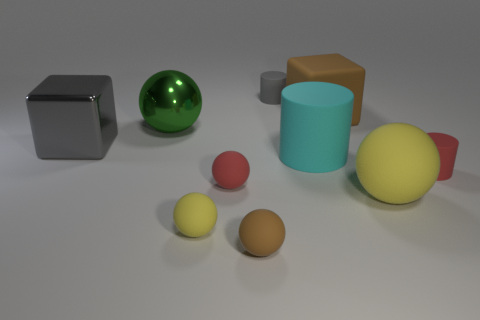Subtract all green balls. How many balls are left? 4 Subtract all tiny brown rubber balls. How many balls are left? 4 Subtract all cyan balls. Subtract all gray blocks. How many balls are left? 5 Subtract all cylinders. How many objects are left? 7 Add 5 small purple matte spheres. How many small purple matte spheres exist? 5 Subtract 1 brown spheres. How many objects are left? 9 Subtract all small brown rubber objects. Subtract all gray metal objects. How many objects are left? 8 Add 3 gray matte cylinders. How many gray matte cylinders are left? 4 